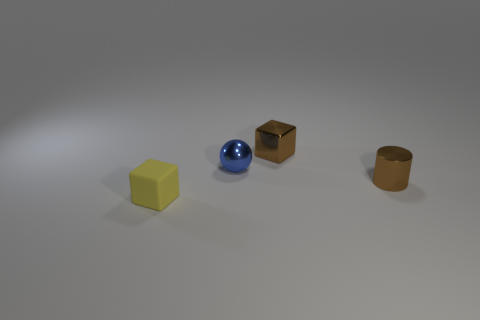Add 3 large blue rubber cylinders. How many objects exist? 7 Subtract all cylinders. How many objects are left? 3 Add 1 large red metallic blocks. How many large red metallic blocks exist? 1 Subtract 0 cyan blocks. How many objects are left? 4 Subtract all cyan objects. Subtract all metal cylinders. How many objects are left? 3 Add 1 brown metallic blocks. How many brown metallic blocks are left? 2 